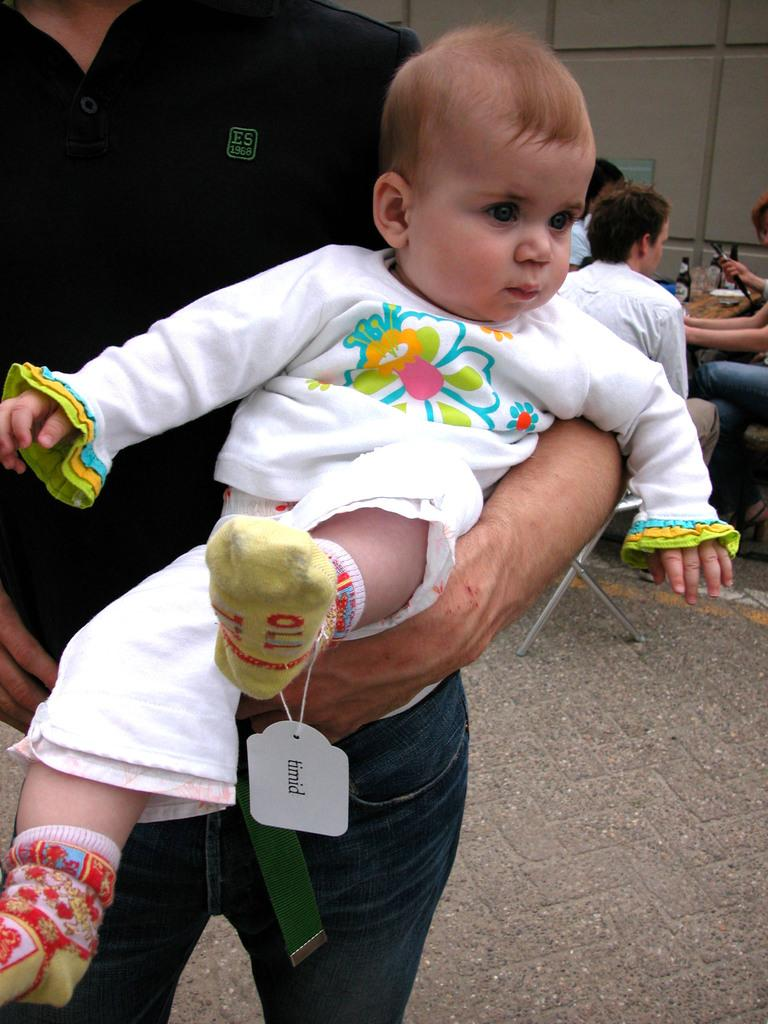What is the person in the image doing? The person is holding a baby in the image. How is the baby dressed? The baby is wearing a white dress. What can be seen on the right side of the image? There are people sitting on the right side of the image. What items are present on the table in the image? There are wine bottles on a table in the image. Can you see a patch on the baby's dress in the image? There is no mention of a patch on the baby's dress in the provided facts, so we cannot determine its presence from the image. Are there any squirrels visible in the image? There is no mention of squirrels in the provided facts, so we cannot determine their presence from the image. 